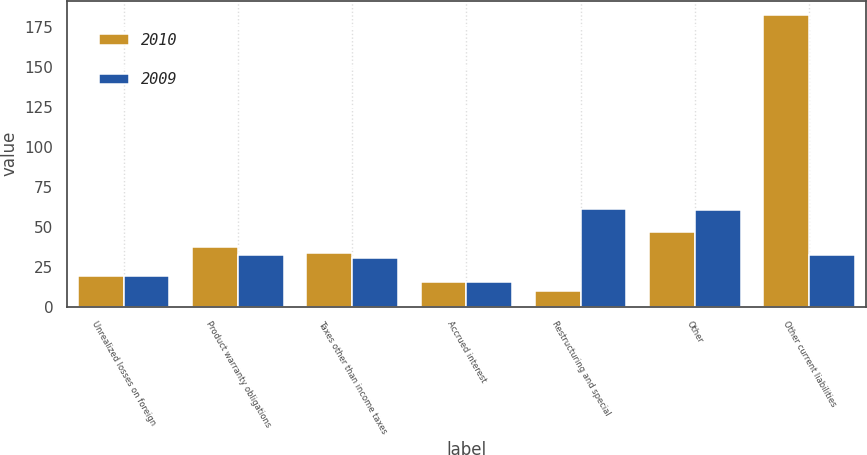<chart> <loc_0><loc_0><loc_500><loc_500><stacked_bar_chart><ecel><fcel>Unrealized losses on foreign<fcel>Product warranty obligations<fcel>Taxes other than income taxes<fcel>Accrued interest<fcel>Restructuring and special<fcel>Other<fcel>Other current liabilities<nl><fcel>2010<fcel>18.9<fcel>37.3<fcel>33.3<fcel>15.6<fcel>9.9<fcel>46.5<fcel>182.1<nl><fcel>2009<fcel>19.1<fcel>32.1<fcel>30.3<fcel>15.6<fcel>60.8<fcel>60.7<fcel>32.1<nl></chart> 